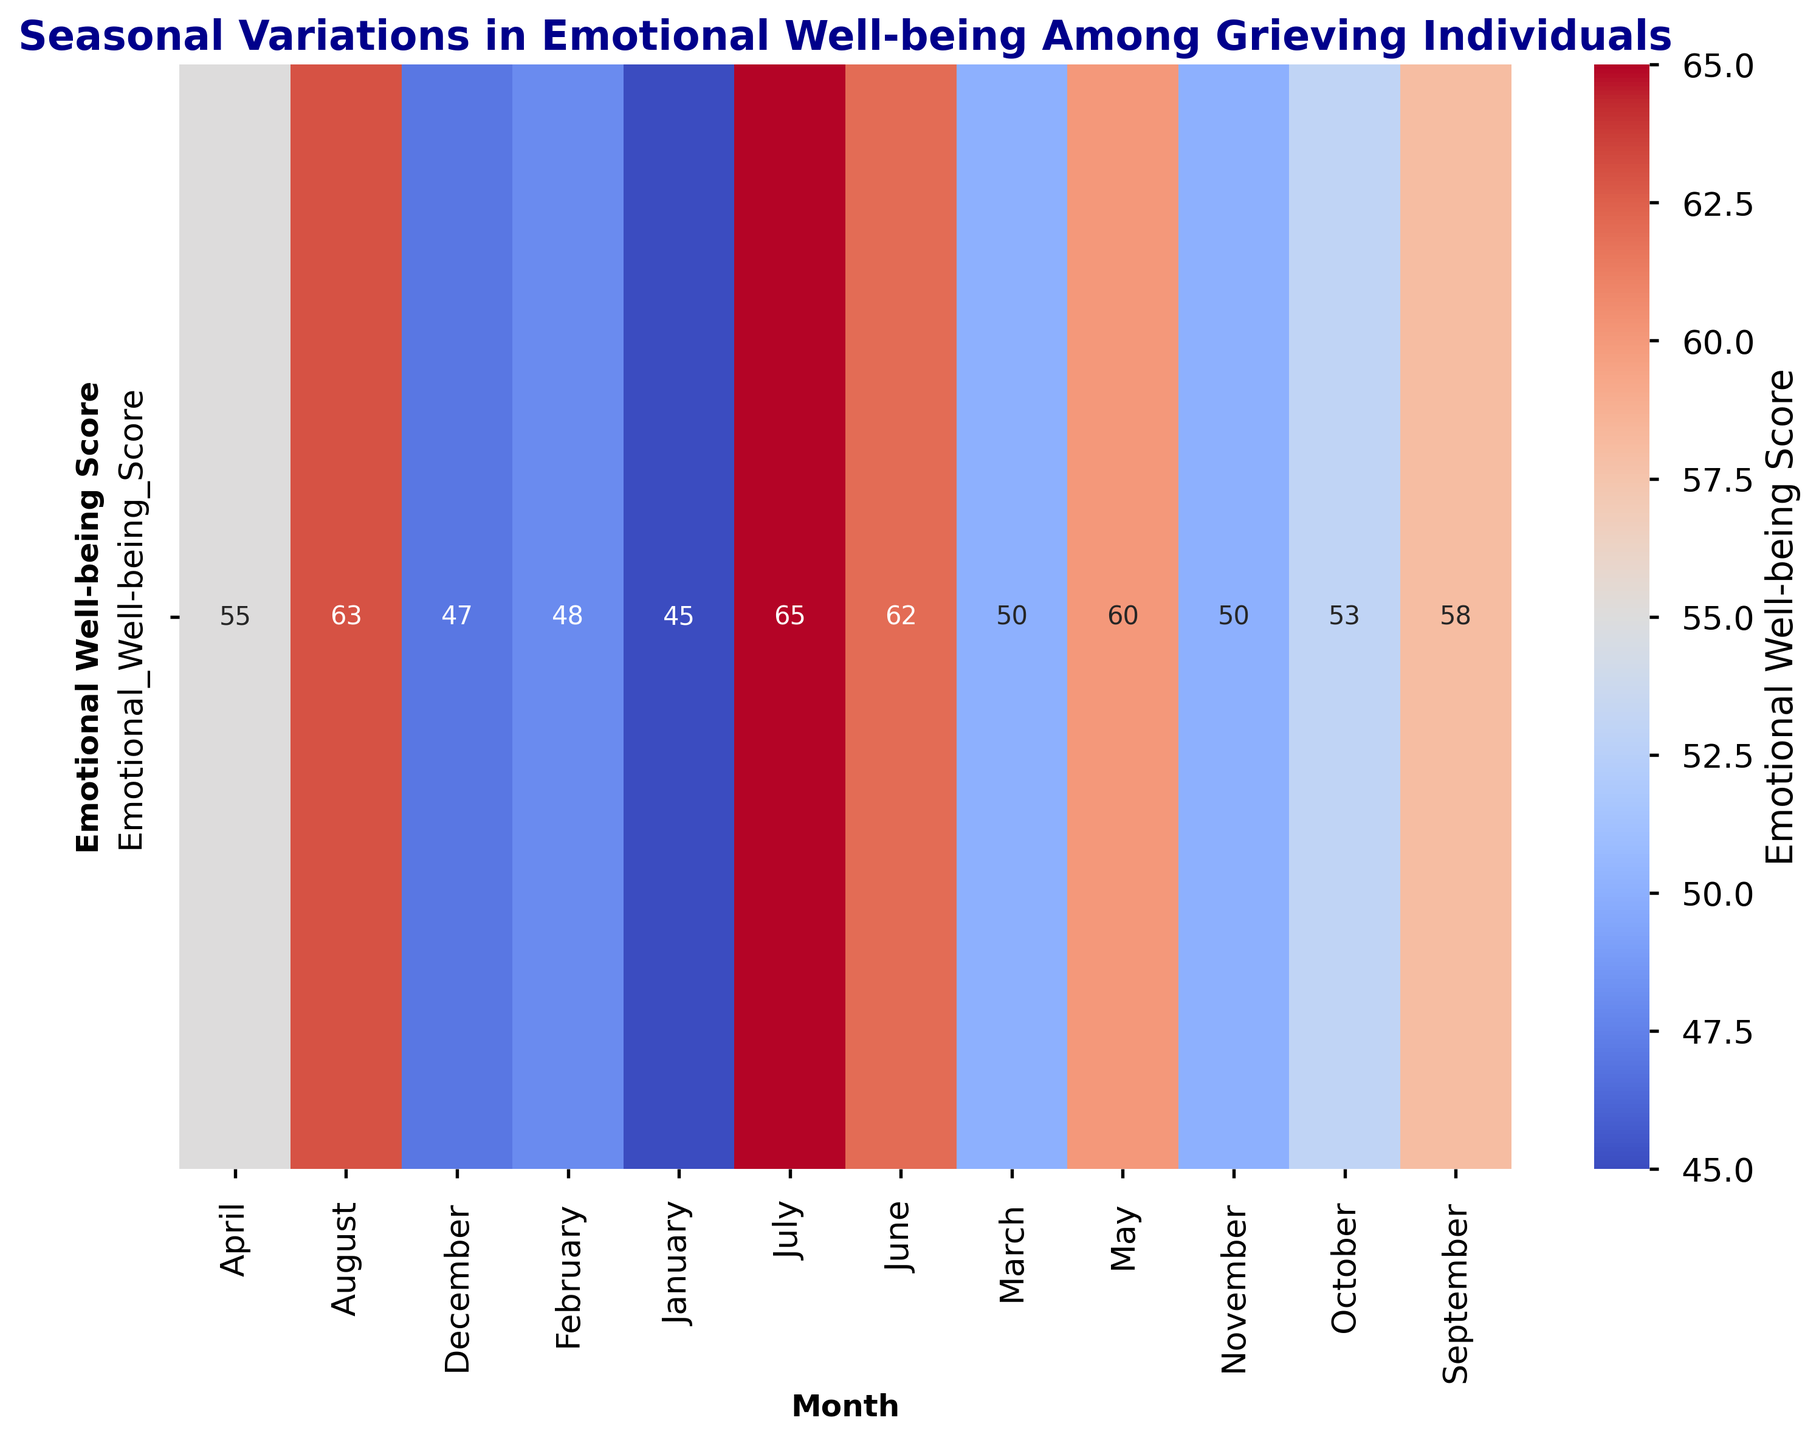what is the general trend in emotional well-being scores throughout the year? The heatmap shows variations in colors corresponding to the scores from January to December. Observing the overall color gradient, we can see emotional well-being scores tend to increase from January through summer months, peaking in July, and then gradually decrease from September to December.
Answer: Scores increase in the first half of the year, peak in July, and then decrease in the second half Which month has the highest emotional well-being score? By inspecting the heatmap, the highest score shows the most intense color on the color gradient, specific to July with a value of 65.
Answer: July Which two months have the lowest emotional well-being scores? Examining the heatmap visually, the months with the darkest colors in the gradient (indicating lower scores) are January and December, each with scores of 45 and 47 respectively.
Answer: January and December How does the well-being score in February compare to October? February has a score of 48, seen by its corresponding color in the heatmap. Meanwhile, October has a score of 53, indicated by a lighter color. So, October’s score is higher.
Answer: October’s score is higher What is the difference in emotional well-being scores between March and September? Referencing the heatmap, March has a score of 50 and September has a score of 58. Subtracting March's score from September's, we get 58 - 50 = 8.
Answer: 8 What is the average emotional well-being score for the summer months (June-August)? The heatmap shows June with 62, July with 65, and August with 63. The sum is 62 + 65 + 63 = 190. Dividing by the number of months (3), the average score is 190 / 3 ≈ 63.33.
Answer: 63.33 During which consecutive pair of months does emotional well-being increase by the largest margin? Examining month-to-month changes on the heatmap shows the largest increase between April (55) and May (60), with a difference of 5.
Answer: Between April and May What is the median emotional well-being score for the year? Listing scores: 45, 47, 48, 50, 50, 53, 55, 58, 60, 62, 63, 65, the median is the middle value in an ordered list. With 12 months, the median falls between the 6th and 7th items: 53 and 55. Average these to get (53 + 55)/2 = 54.
Answer: 54 Which season shows the highest average emotional well-being score? (Assume winter: Dec-Feb, spring: Mar-May, summer: Jun-Aug, autumn: Sep-Nov) Average the scores for each season indicated by the heatmap: Winter (47+48+45)/3 = 46.67, Spring (50+55+60)/3 = 55, Summer (62+65+63)/3 = 63.33, Autumn (58+53+50)/3 = 53.67. Therefore, summer has the highest average score.
Answer: Summer 